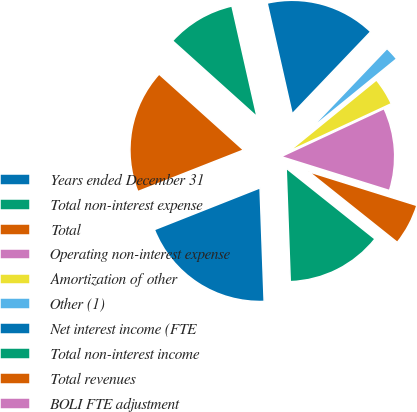Convert chart. <chart><loc_0><loc_0><loc_500><loc_500><pie_chart><fcel>Years ended December 31<fcel>Total non-interest expense<fcel>Total<fcel>Operating non-interest expense<fcel>Amortization of other<fcel>Other (1)<fcel>Net interest income (FTE<fcel>Total non-interest income<fcel>Total revenues<fcel>BOLI FTE adjustment<nl><fcel>19.58%<fcel>13.71%<fcel>5.89%<fcel>11.76%<fcel>3.94%<fcel>1.99%<fcel>15.67%<fcel>9.8%<fcel>17.62%<fcel>0.03%<nl></chart> 